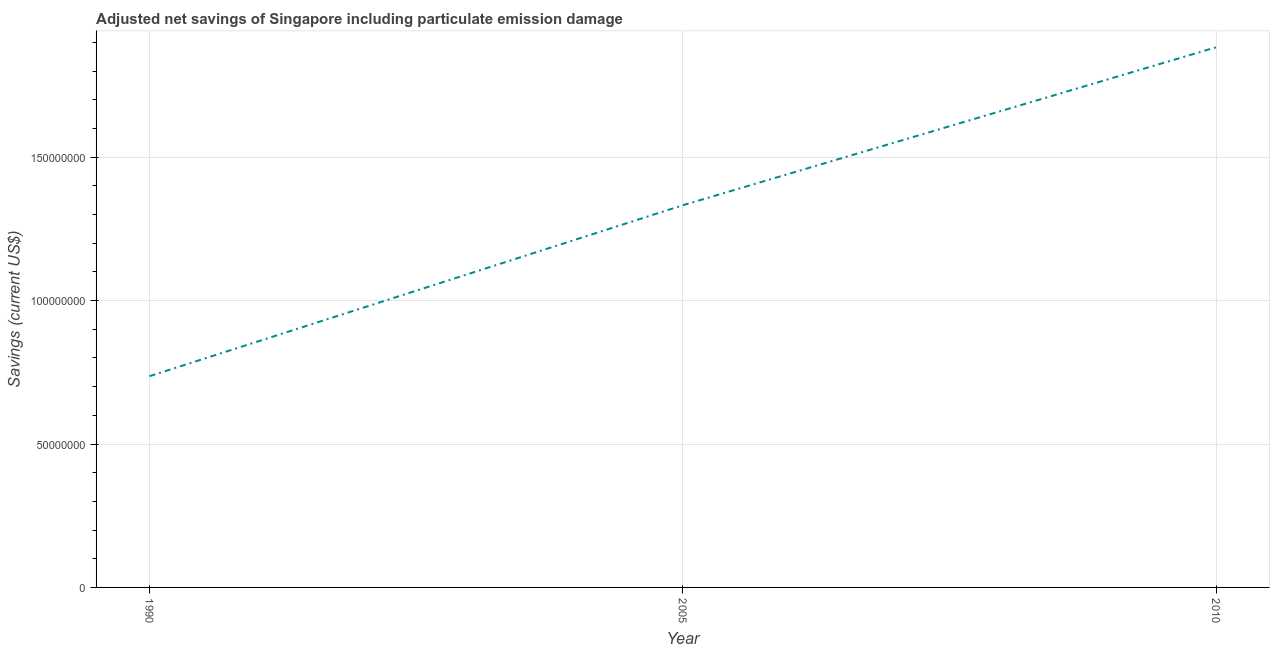What is the adjusted net savings in 2005?
Provide a succinct answer. 1.33e+08. Across all years, what is the maximum adjusted net savings?
Make the answer very short. 1.88e+08. Across all years, what is the minimum adjusted net savings?
Provide a succinct answer. 7.36e+07. In which year was the adjusted net savings minimum?
Provide a short and direct response. 1990. What is the sum of the adjusted net savings?
Your answer should be very brief. 3.95e+08. What is the difference between the adjusted net savings in 1990 and 2005?
Provide a succinct answer. -5.96e+07. What is the average adjusted net savings per year?
Your response must be concise. 1.32e+08. What is the median adjusted net savings?
Your answer should be compact. 1.33e+08. In how many years, is the adjusted net savings greater than 180000000 US$?
Provide a short and direct response. 1. What is the ratio of the adjusted net savings in 1990 to that in 2005?
Provide a short and direct response. 0.55. Is the adjusted net savings in 1990 less than that in 2010?
Your answer should be very brief. Yes. Is the difference between the adjusted net savings in 1990 and 2005 greater than the difference between any two years?
Your answer should be very brief. No. What is the difference between the highest and the second highest adjusted net savings?
Your answer should be compact. 5.51e+07. Is the sum of the adjusted net savings in 1990 and 2010 greater than the maximum adjusted net savings across all years?
Your answer should be very brief. Yes. What is the difference between the highest and the lowest adjusted net savings?
Provide a short and direct response. 1.15e+08. In how many years, is the adjusted net savings greater than the average adjusted net savings taken over all years?
Offer a terse response. 2. Does the adjusted net savings monotonically increase over the years?
Give a very brief answer. Yes. How many lines are there?
Your response must be concise. 1. How many years are there in the graph?
Your answer should be very brief. 3. Are the values on the major ticks of Y-axis written in scientific E-notation?
Your answer should be very brief. No. What is the title of the graph?
Offer a very short reply. Adjusted net savings of Singapore including particulate emission damage. What is the label or title of the Y-axis?
Keep it short and to the point. Savings (current US$). What is the Savings (current US$) of 1990?
Your answer should be very brief. 7.36e+07. What is the Savings (current US$) in 2005?
Your answer should be very brief. 1.33e+08. What is the Savings (current US$) of 2010?
Make the answer very short. 1.88e+08. What is the difference between the Savings (current US$) in 1990 and 2005?
Your answer should be very brief. -5.96e+07. What is the difference between the Savings (current US$) in 1990 and 2010?
Provide a short and direct response. -1.15e+08. What is the difference between the Savings (current US$) in 2005 and 2010?
Offer a terse response. -5.51e+07. What is the ratio of the Savings (current US$) in 1990 to that in 2005?
Provide a short and direct response. 0.55. What is the ratio of the Savings (current US$) in 1990 to that in 2010?
Ensure brevity in your answer.  0.39. What is the ratio of the Savings (current US$) in 2005 to that in 2010?
Give a very brief answer. 0.71. 